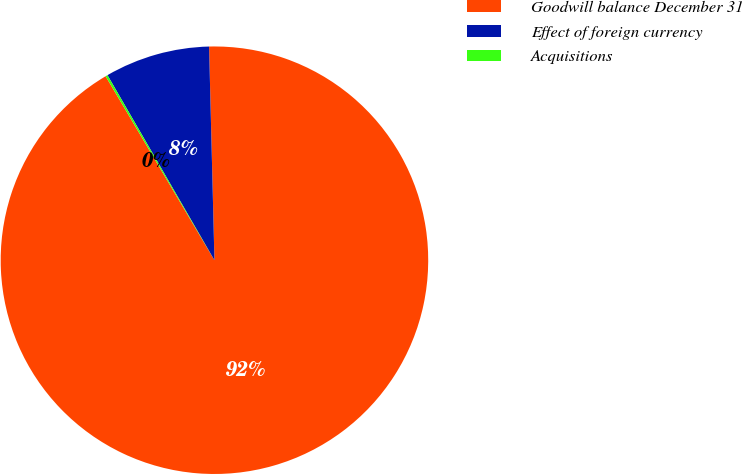Convert chart to OTSL. <chart><loc_0><loc_0><loc_500><loc_500><pie_chart><fcel>Goodwill balance December 31<fcel>Effect of foreign currency<fcel>Acquisitions<nl><fcel>91.9%<fcel>7.94%<fcel>0.16%<nl></chart> 